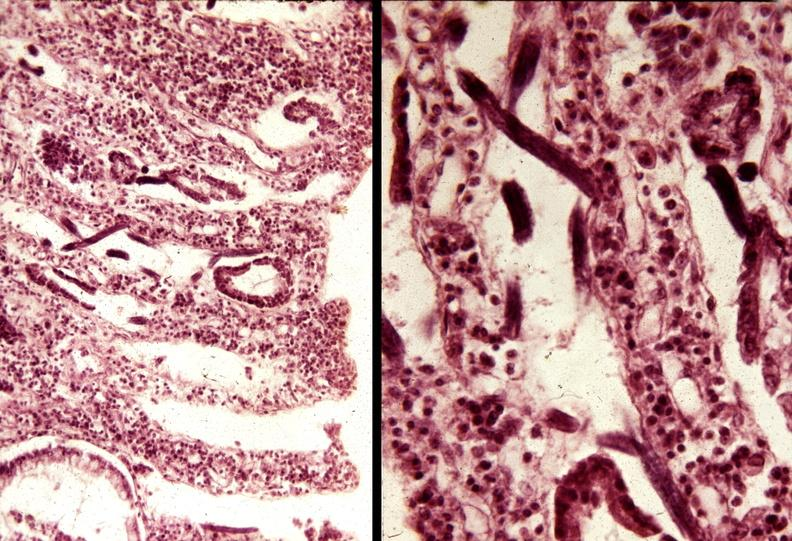s fat necrosis present?
Answer the question using a single word or phrase. No 